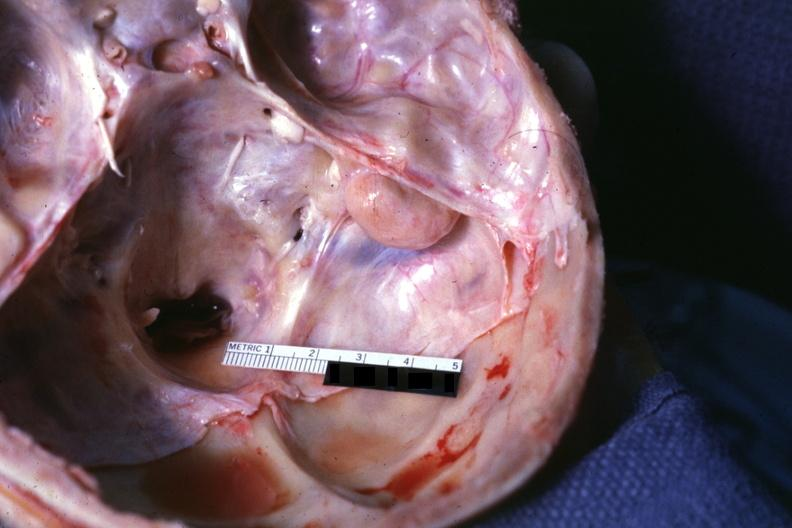how is lesion seen on surface right bone?
Answer the question using a single word or phrase. Petrous 